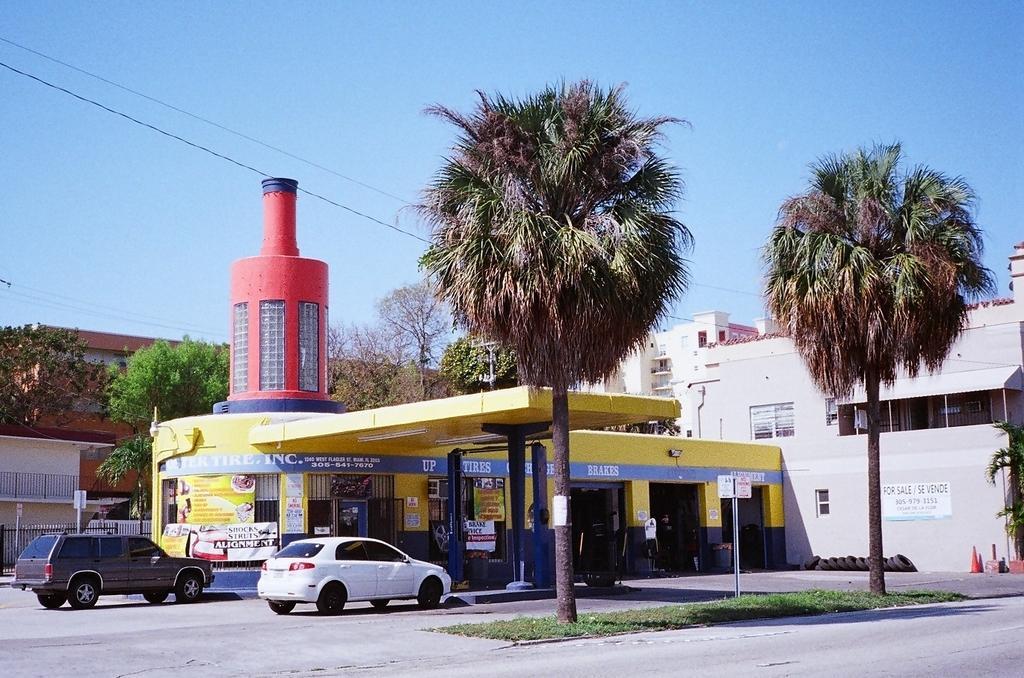Can you describe this image briefly? In this image there is a store in the middle. At the top there is the sky. On the right side there is the building. In front of the store there are two cars. In the middle there are two trees on the ground. At the top there are wires. 